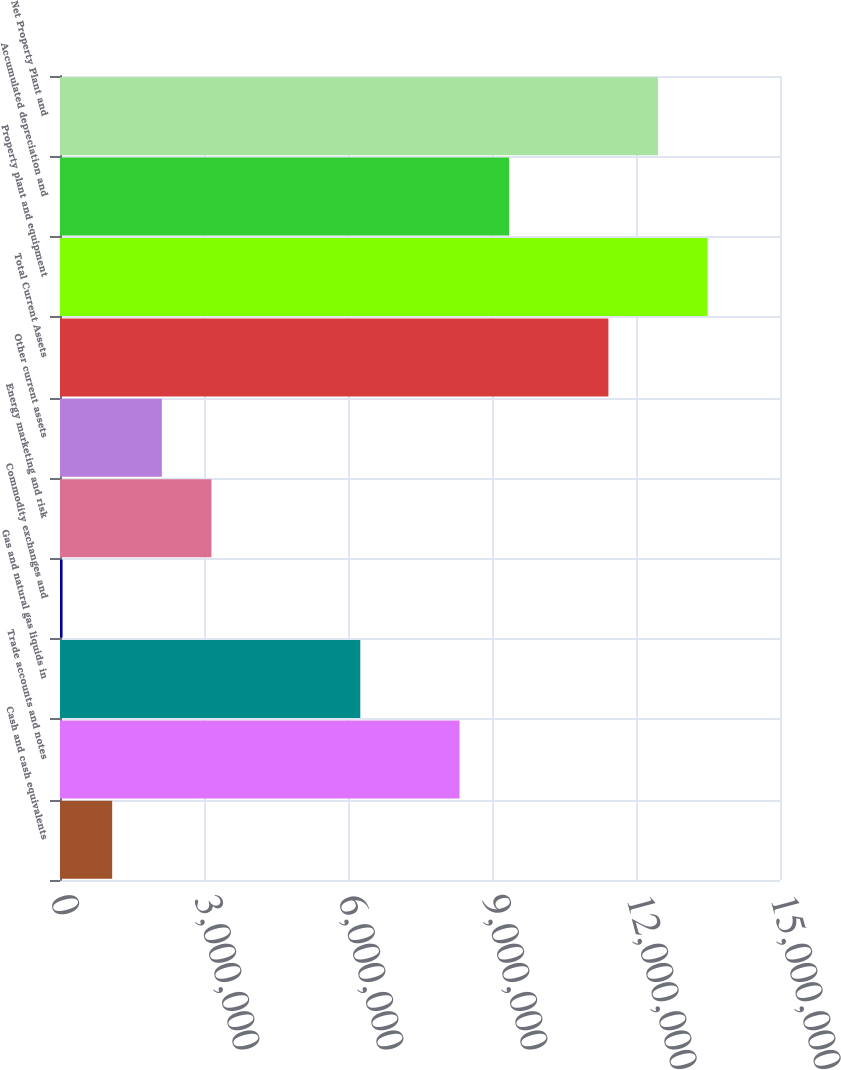<chart> <loc_0><loc_0><loc_500><loc_500><bar_chart><fcel>Cash and cash equivalents<fcel>Trade accounts and notes<fcel>Gas and natural gas liquids in<fcel>Commodity exchanges and<fcel>Energy marketing and risk<fcel>Other current assets<fcel>Total Current Assets<fcel>Property plant and equipment<fcel>Accumulated depreciation and<fcel>Net Property Plant and<nl><fcel>1.0872e+06<fcel>8.32355e+06<fcel>6.25602e+06<fcel>53433<fcel>3.15473e+06<fcel>2.12096e+06<fcel>1.14248e+07<fcel>1.34924e+07<fcel>9.35732e+06<fcel>1.24586e+07<nl></chart> 